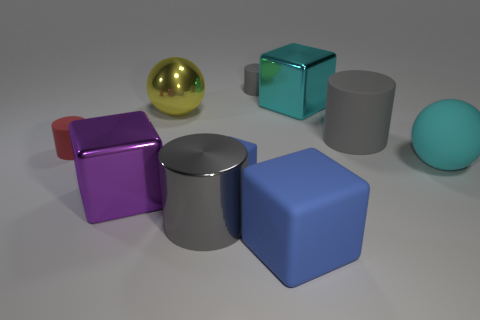Can you tell me about the colors of the objects? Certainly! The image features objects in a range of colors: there's a purple cube with a glossy finish, a shiny golden sphere, a translucent teal cube, a matte gray cylinder, a matte blue cube, and a soft cyan sphere with a matte finish. 